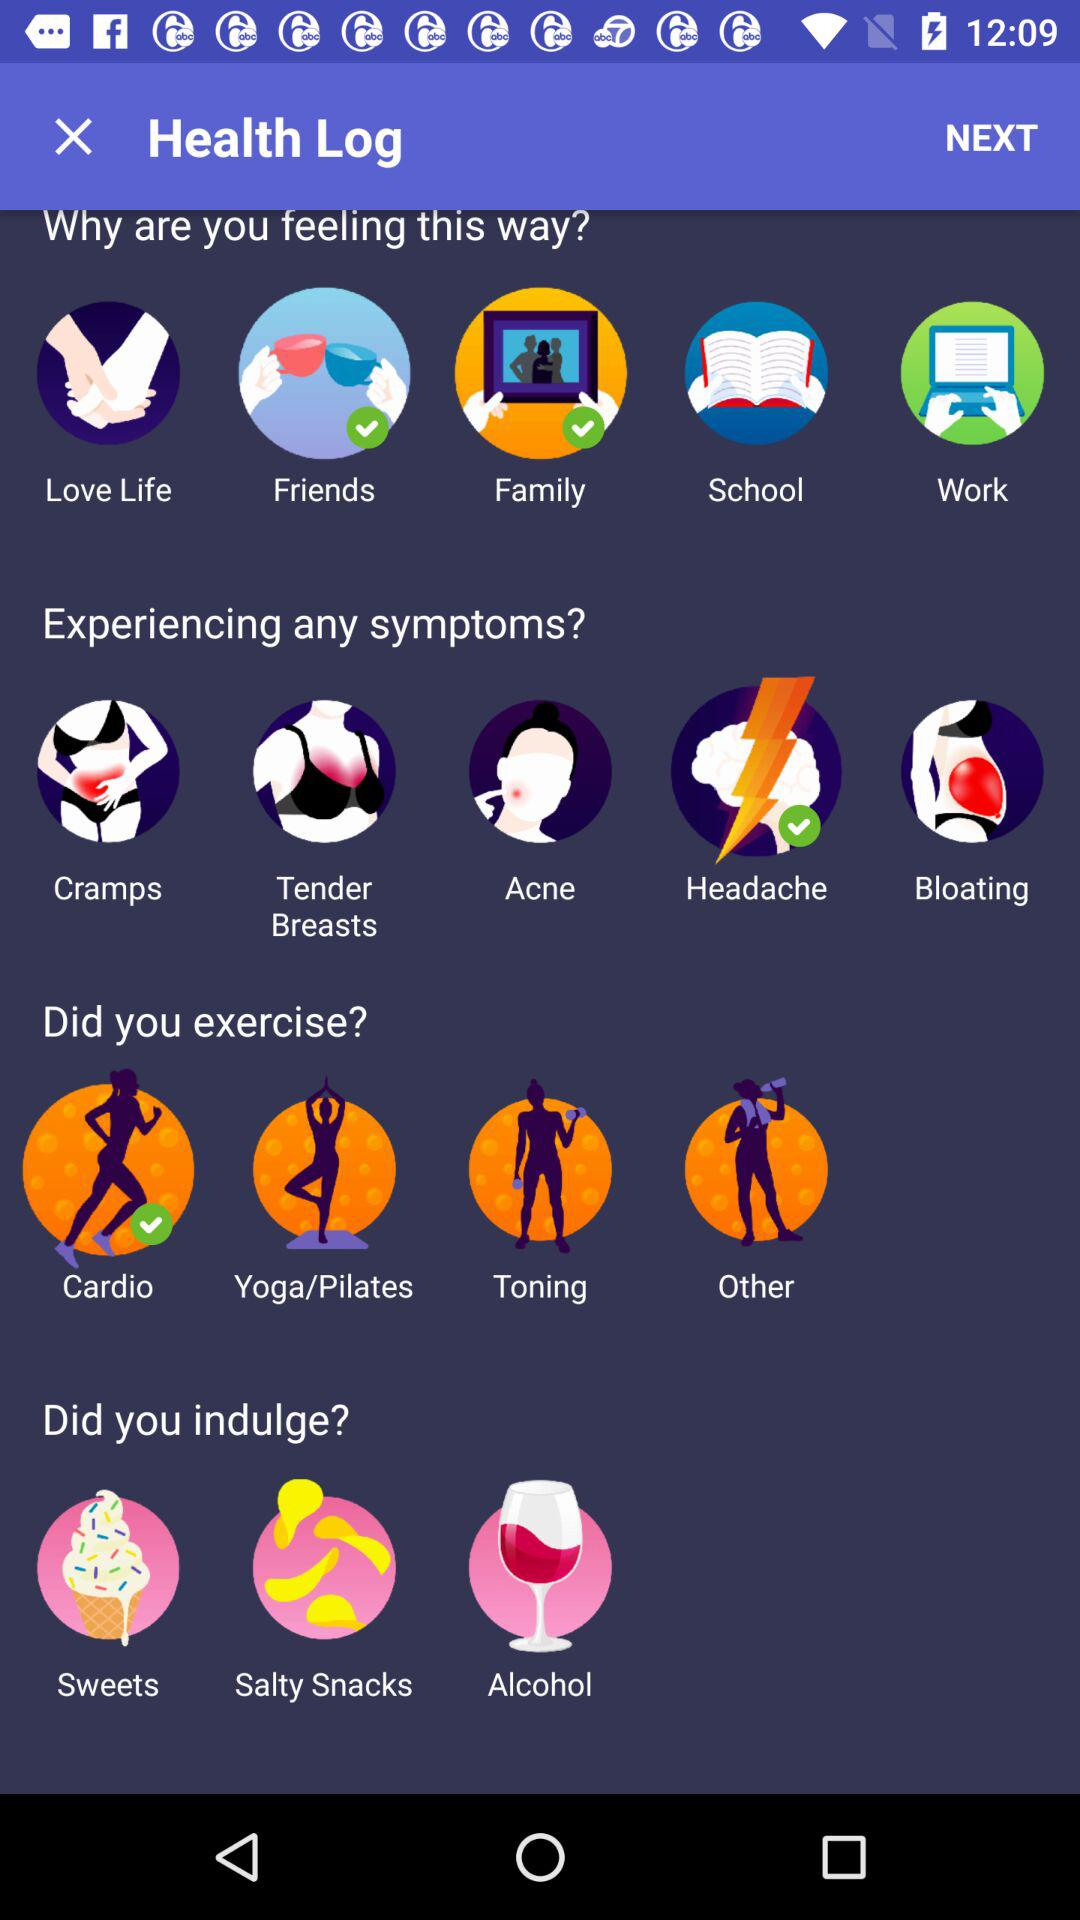What's the selected Symptom? The selected symptom is headache. 